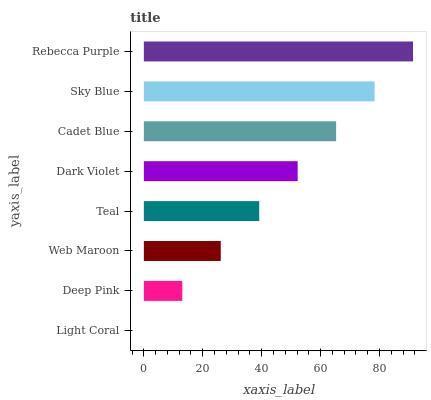Is Light Coral the minimum?
Answer yes or no. Yes. Is Rebecca Purple the maximum?
Answer yes or no. Yes. Is Deep Pink the minimum?
Answer yes or no. No. Is Deep Pink the maximum?
Answer yes or no. No. Is Deep Pink greater than Light Coral?
Answer yes or no. Yes. Is Light Coral less than Deep Pink?
Answer yes or no. Yes. Is Light Coral greater than Deep Pink?
Answer yes or no. No. Is Deep Pink less than Light Coral?
Answer yes or no. No. Is Dark Violet the high median?
Answer yes or no. Yes. Is Teal the low median?
Answer yes or no. Yes. Is Rebecca Purple the high median?
Answer yes or no. No. Is Dark Violet the low median?
Answer yes or no. No. 